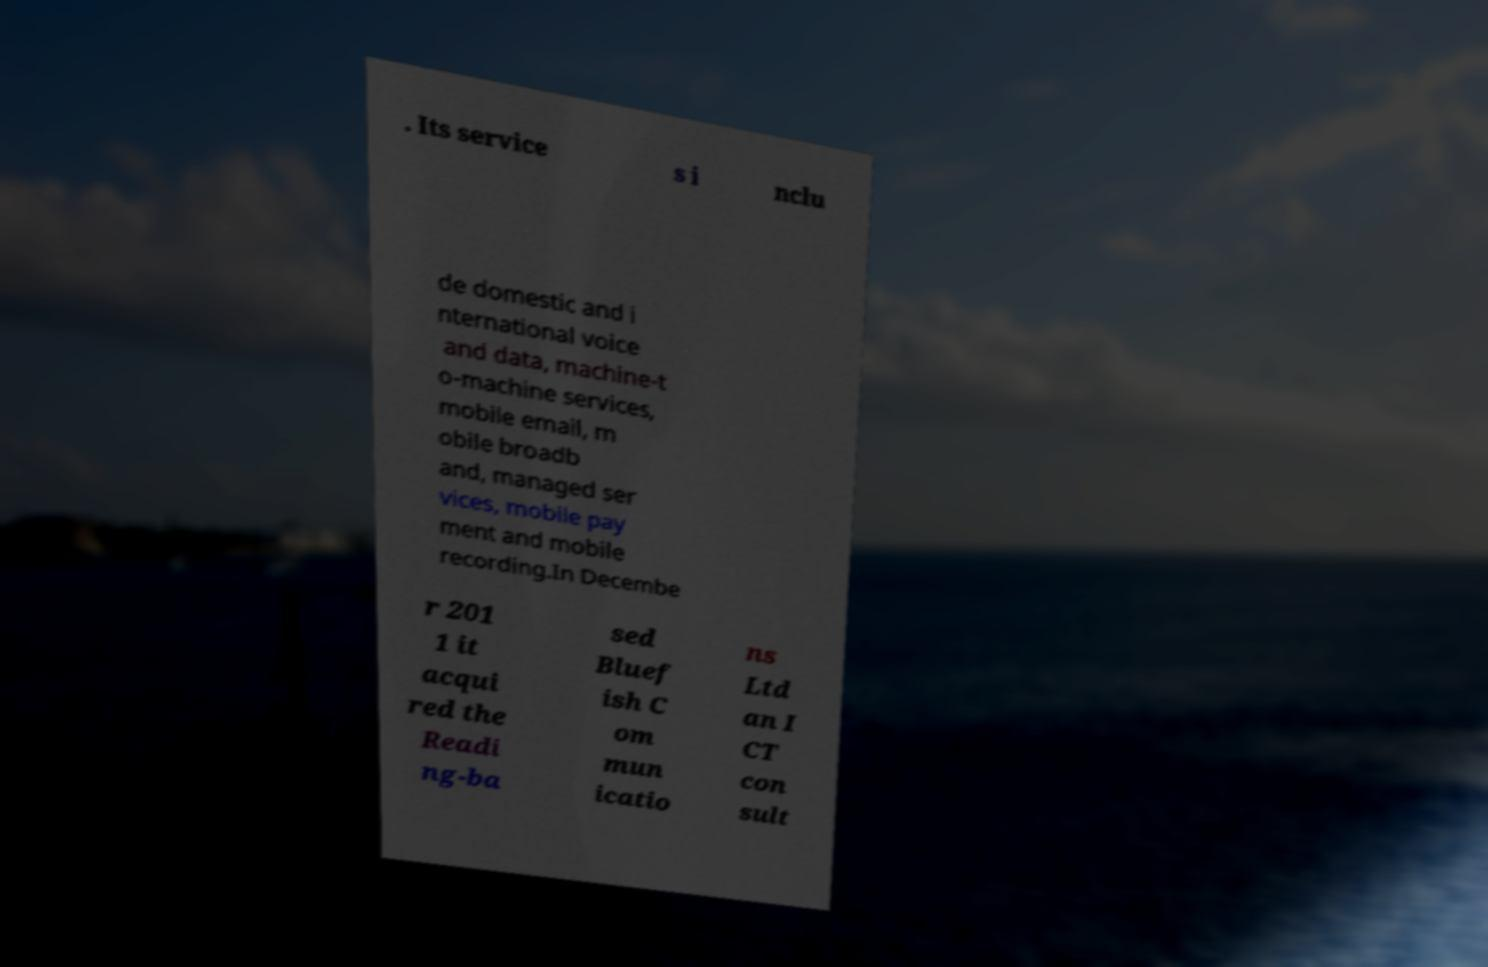There's text embedded in this image that I need extracted. Can you transcribe it verbatim? . Its service s i nclu de domestic and i nternational voice and data, machine-t o-machine services, mobile email, m obile broadb and, managed ser vices, mobile pay ment and mobile recording.In Decembe r 201 1 it acqui red the Readi ng-ba sed Bluef ish C om mun icatio ns Ltd an I CT con sult 